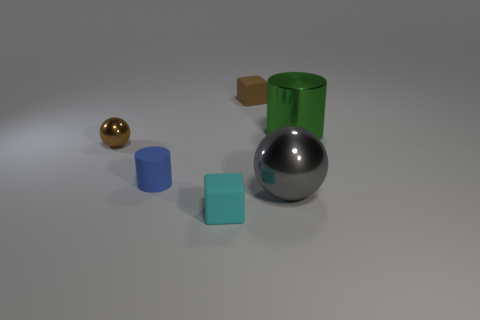Do the rubber cylinder and the gray metal sphere have the same size?
Provide a short and direct response. No. Is the size of the cyan rubber cube the same as the sphere to the right of the matte cylinder?
Offer a very short reply. No. How many small cubes have the same color as the tiny metal ball?
Your response must be concise. 1. Are the brown object on the left side of the brown rubber block and the gray thing made of the same material?
Keep it short and to the point. Yes. Is the number of balls that are on the left side of the gray thing greater than the number of large metal cylinders to the left of the blue rubber cylinder?
Give a very brief answer. Yes. There is a brown block that is the same size as the blue object; what is it made of?
Provide a short and direct response. Rubber. There is a small matte object that is behind the large green metallic object; is its shape the same as the matte object in front of the rubber cylinder?
Keep it short and to the point. Yes. How many other objects are there of the same color as the big ball?
Offer a very short reply. 0. Is the material of the small cube that is in front of the blue thing the same as the small cube that is behind the tiny cyan rubber cube?
Your answer should be very brief. Yes. Is the number of brown things that are on the right side of the green metallic cylinder the same as the number of objects on the right side of the brown sphere?
Your response must be concise. No. 